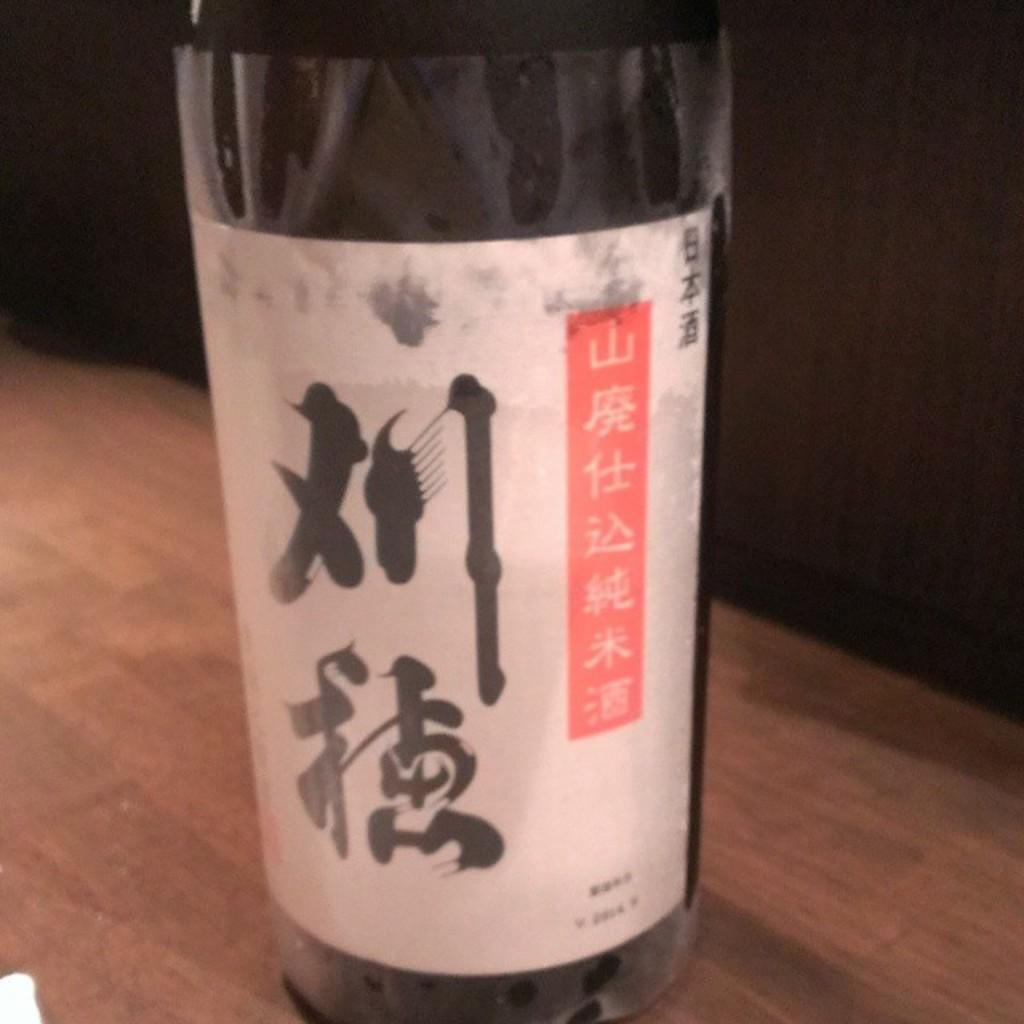What can be seen in the image? There is a bottle in the image. Where is the bottle located? The bottle is on a wooden surface. Are there any additional features on the bottle? Yes, there is a sticker on the bottle. What can be observed about the background of the image? The background of the image is dark. How many minutes does it take for the popcorn to pop in the image? There is no popcorn present in the image, so it is not possible to determine how long it would take to pop. 